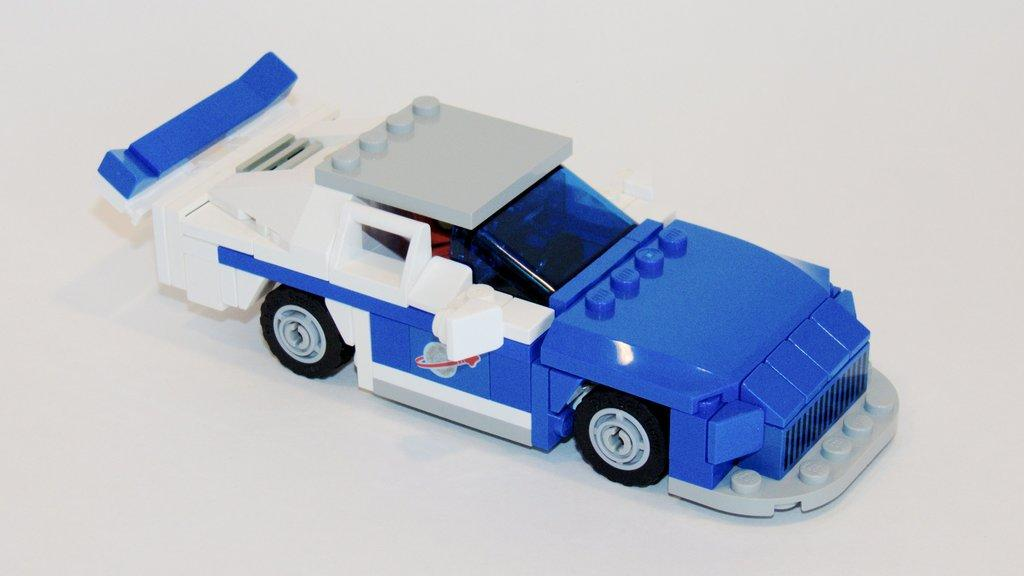What type of toy is in the image? There is a toy car in the image. What colors can be seen on the toy car? The toy car has blue and white colors. What is the toy car placed on in the image? The toy car is on a white surface. How many crackers are being used to add to the toy car's performance in the image? There is no mention of crackers or any addition to the toy car's performance in the image. The toy car is simply placed on a white surface. 